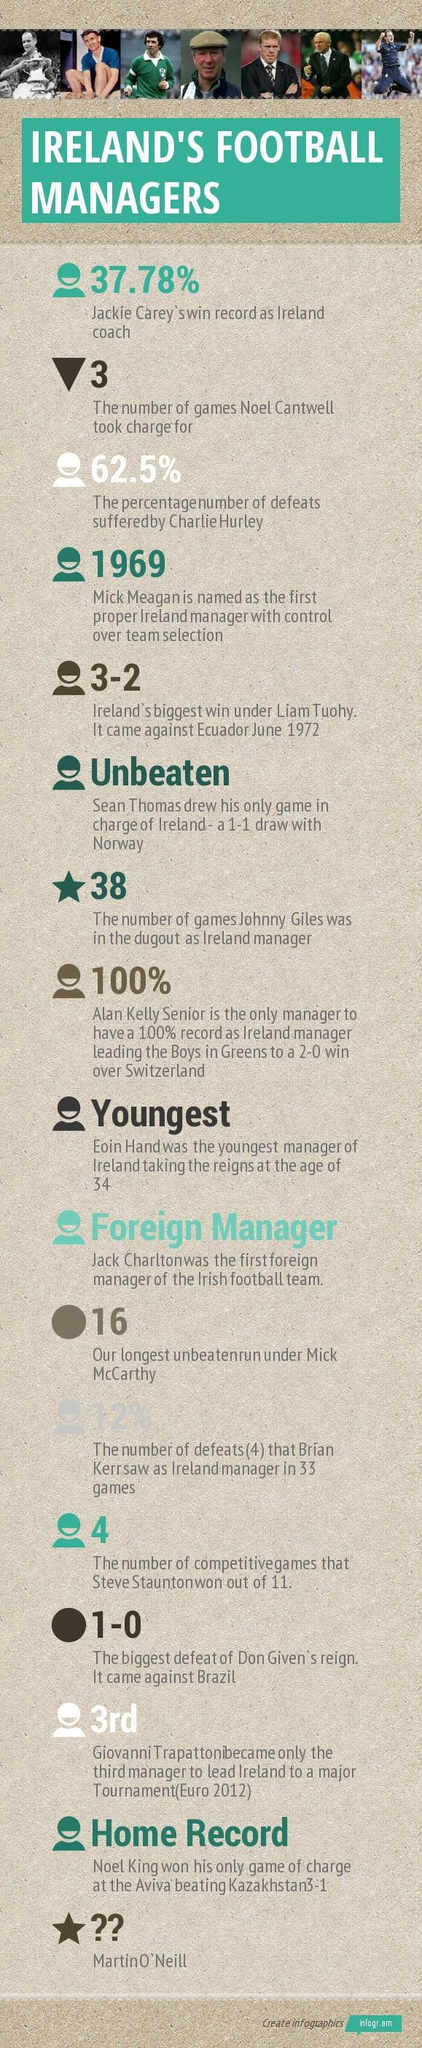What is the percentage of defeats suffered by Charlie Hurley?
Answer the question with a short phrase. 62.5% 